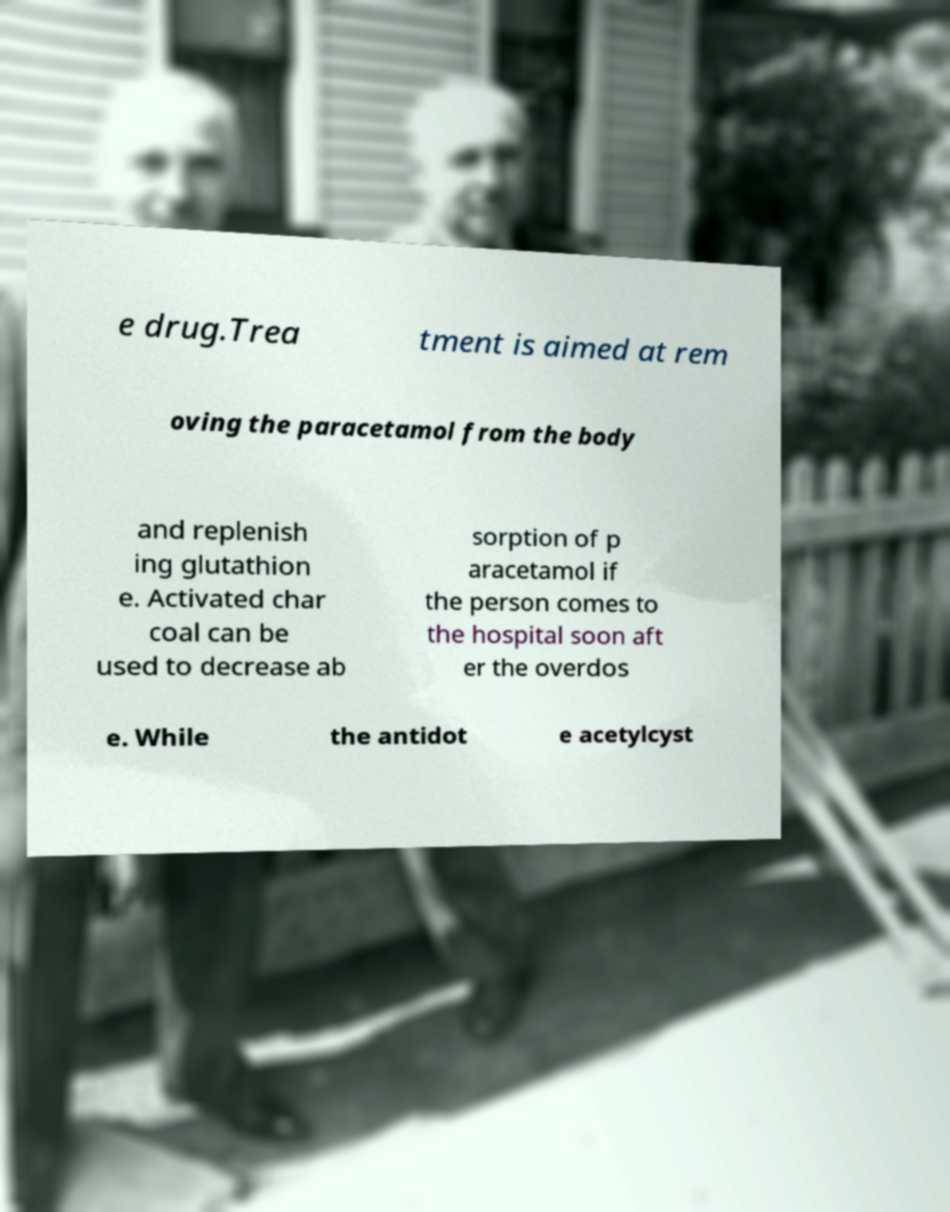I need the written content from this picture converted into text. Can you do that? e drug.Trea tment is aimed at rem oving the paracetamol from the body and replenish ing glutathion e. Activated char coal can be used to decrease ab sorption of p aracetamol if the person comes to the hospital soon aft er the overdos e. While the antidot e acetylcyst 